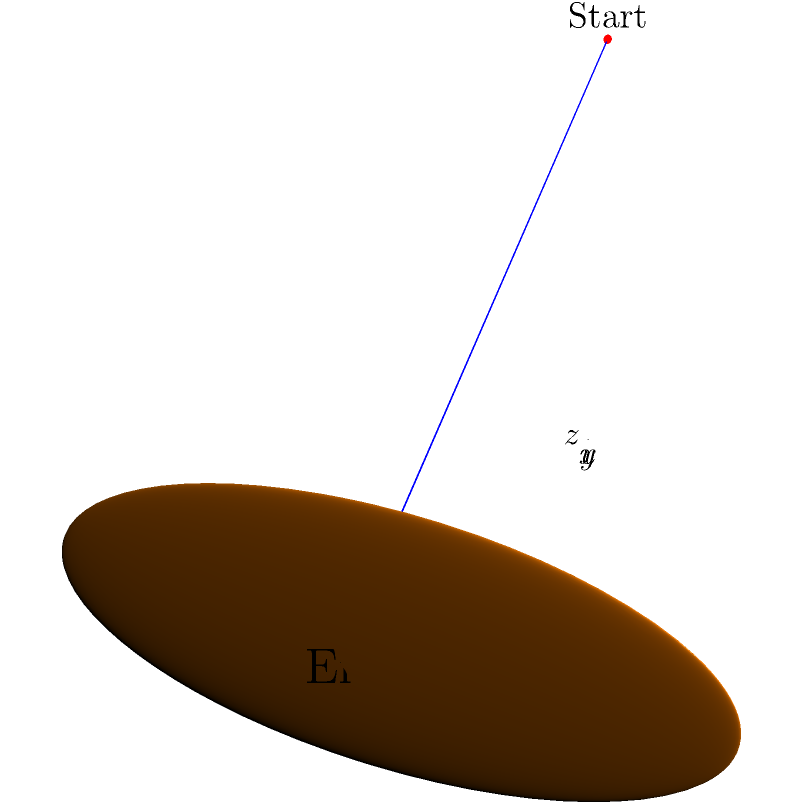As the team's unofficial counselor and a fellow baseball player, you're helping a pitcher visualize their pitch trajectory. Using the 3D coordinate system shown, where the x-axis represents the distance to home plate, the y-axis represents the horizontal deviation, and the z-axis represents the height, describe the path of the pitch. What type of pitch does this trajectory likely represent, and how might understanding this help the pitcher's mental game? Let's break down the trajectory and its implications:

1. Starting point: The ball begins at coordinates approximately (0, 0, 2), indicating it's released about 2 units high.

2. Ending point: The ball ends at around (30, 0, 0), suggesting it travels 30 units towards home plate and ends at ground level.

3. Path shape: The trajectory follows a smooth curve that descends as it moves forward, with no horizontal deviation (y-axis remains at 0).

4. Pitch type: This trajectory is characteristic of a fastball or a straight pitch. It doesn't show the sharp breaking motion of a curveball or the lateral movement of a slider.

5. Mental game implications:
   a) Consistency: The straight path suggests good control, which can boost the pitcher's confidence.
   b) Visualization: Understanding the pitch's path can help the pitcher mentally rehearse and refine their technique.
   c) Strategy: Knowing the fastball's trajectory allows the pitcher to strategize how to mix in breaking balls for contrast.
   d) Focus: Visualizing this clean trajectory can serve as a mental reset between pitches, promoting concentration.

6. Psychological perspective: This visual representation can serve as a powerful tool for mental imagery, a key technique in sports psychology. It allows the pitcher to internalize the ideal path, potentially improving performance and reducing anxiety.

Understanding and visualizing this trajectory can enhance the pitcher's self-awareness, confidence, and overall mental approach to the game.
Answer: Fastball; aids visualization, confidence, and mental preparation 